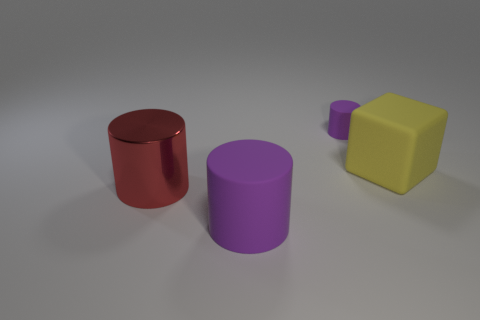Subtract all big purple rubber cylinders. How many cylinders are left? 2 Add 4 yellow matte things. How many objects exist? 8 Subtract 1 cylinders. How many cylinders are left? 2 Subtract all red cylinders. How many cylinders are left? 2 Subtract all cylinders. How many objects are left? 1 Subtract all yellow cylinders. Subtract all yellow cubes. How many cylinders are left? 3 Subtract all blue balls. How many red cylinders are left? 1 Subtract all big purple matte things. Subtract all big purple things. How many objects are left? 2 Add 3 big metallic things. How many big metallic things are left? 4 Add 4 big yellow blocks. How many big yellow blocks exist? 5 